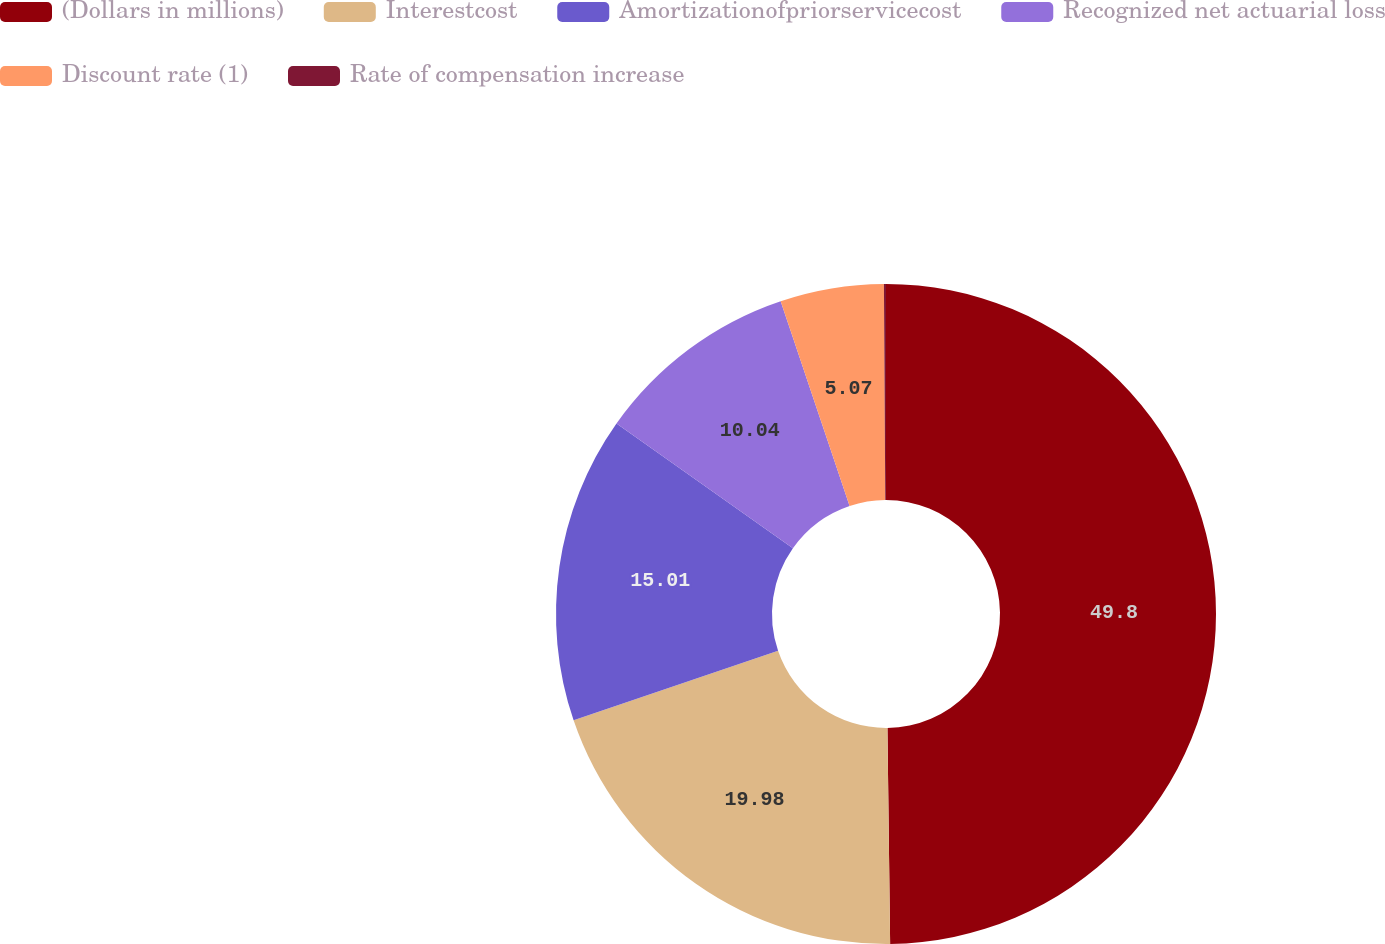Convert chart. <chart><loc_0><loc_0><loc_500><loc_500><pie_chart><fcel>(Dollars in millions)<fcel>Interestcost<fcel>Amortizationofpriorservicecost<fcel>Recognized net actuarial loss<fcel>Discount rate (1)<fcel>Rate of compensation increase<nl><fcel>49.8%<fcel>19.98%<fcel>15.01%<fcel>10.04%<fcel>5.07%<fcel>0.1%<nl></chart> 